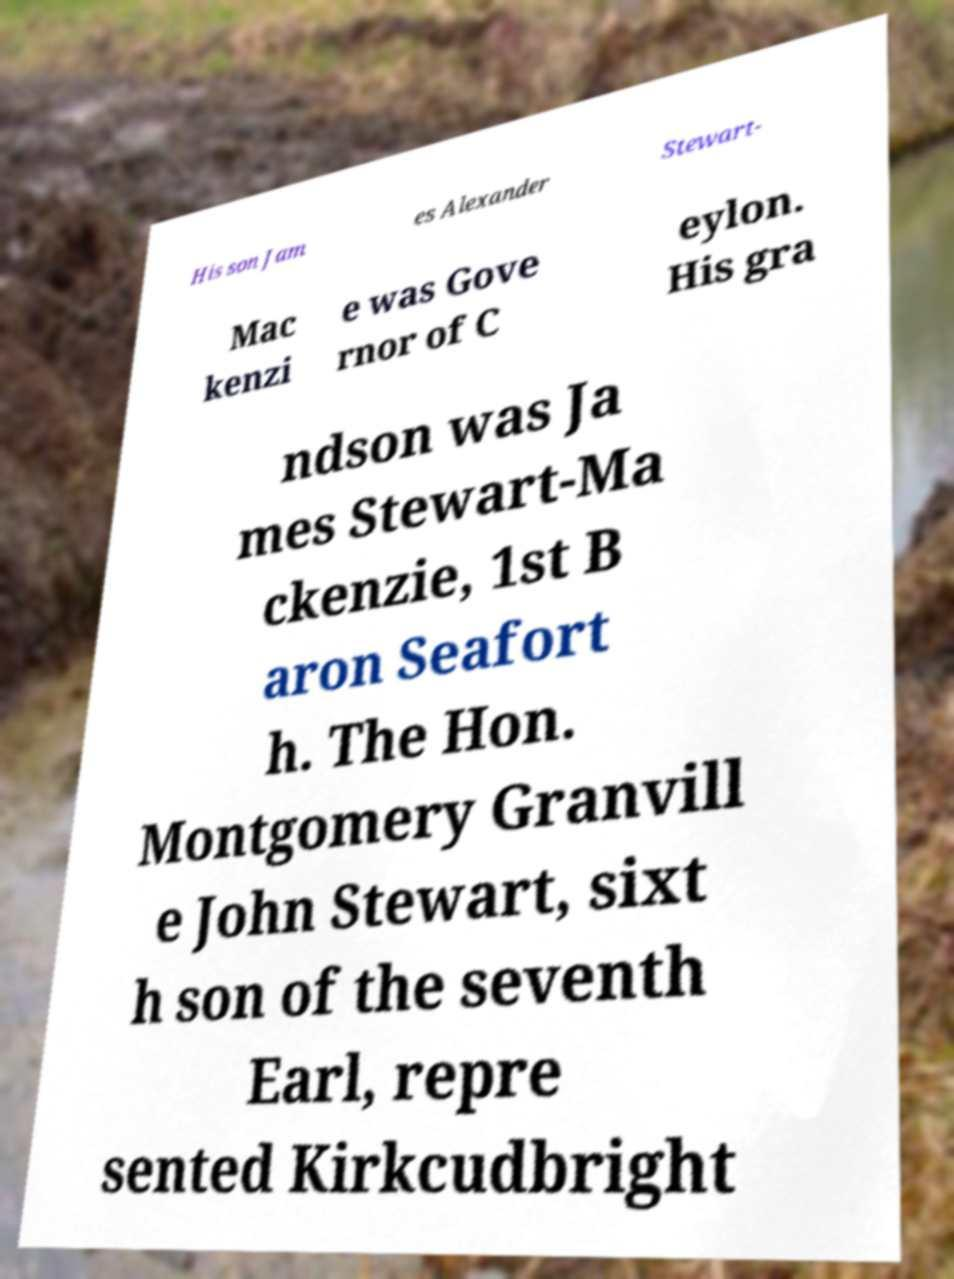What messages or text are displayed in this image? I need them in a readable, typed format. His son Jam es Alexander Stewart- Mac kenzi e was Gove rnor of C eylon. His gra ndson was Ja mes Stewart-Ma ckenzie, 1st B aron Seafort h. The Hon. Montgomery Granvill e John Stewart, sixt h son of the seventh Earl, repre sented Kirkcudbright 